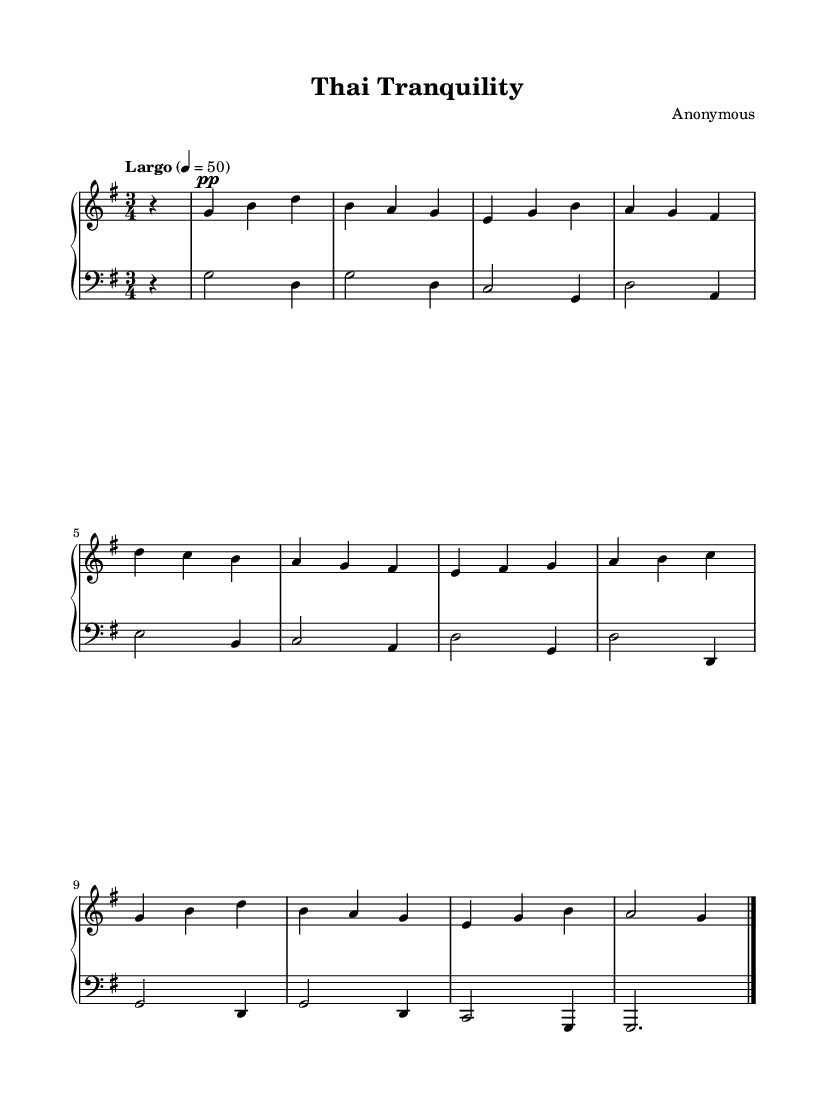What is the key signature of this music? The key signature is indicated by the sharp or flat symbols placed at the beginning of the staff. In this score, there are no sharps or flats shown, which means it is in G major.
Answer: G major What is the time signature of this music? The time signature is found at the beginning of the staff, following the key signature. Here, it is displayed as 3/4, meaning there are three beats in each measure and the quarter note gets one beat.
Answer: 3/4 What is the tempo marking of this piece? The tempo marking is usually written above the staff and indicates the speed of the piece. In this score, "Largo" is noted, indicating a slow tempo, along with the specific beats per minute of 50.
Answer: Largo How many measures are in the piece? To determine the number of measures, you can count the vertical lines (bar lines) throughout the score. There are ten measures from the beginning to the final bar line.
Answer: 10 What is the time signature's beat pattern in this composition? The time signature 3/4 indicates that each measure contains three beats, which can be further examined in the distribution of notes and rests. Each measure consistently has three beats, confirming the expected pattern throughout.
Answer: 3 beats What is the dynamic marking for the right hand at the beginning? The dynamic marking directs how the notes should be played, in this case, it is indicated with "pp", which means "pianissimo" or very soft. This marking appears before the first note in the right hand.
Answer: pp 